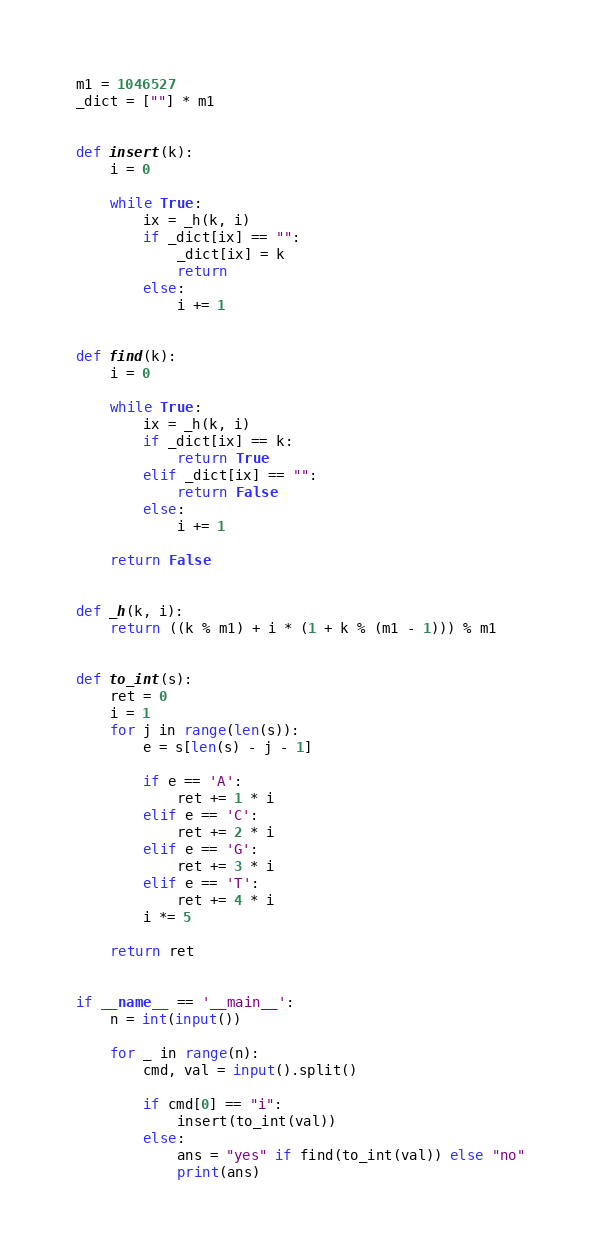Convert code to text. <code><loc_0><loc_0><loc_500><loc_500><_Python_>m1 = 1046527
_dict = [""] * m1


def insert(k):
    i = 0

    while True:
        ix = _h(k, i)
        if _dict[ix] == "":
            _dict[ix] = k
            return
        else:
            i += 1


def find(k):
    i = 0

    while True:
        ix = _h(k, i)
        if _dict[ix] == k:
            return True
        elif _dict[ix] == "":
            return False
        else:
            i += 1

    return False


def _h(k, i):
    return ((k % m1) + i * (1 + k % (m1 - 1))) % m1


def to_int(s):
    ret = 0
    i = 1
    for j in range(len(s)):
        e = s[len(s) - j - 1]

        if e == 'A':
            ret += 1 * i
        elif e == 'C':
            ret += 2 * i
        elif e == 'G':
            ret += 3 * i
        elif e == 'T':
            ret += 4 * i
        i *= 5

    return ret


if __name__ == '__main__':
    n = int(input())

    for _ in range(n):
        cmd, val = input().split()

        if cmd[0] == "i":
            insert(to_int(val))
        else:
            ans = "yes" if find(to_int(val)) else "no"
            print(ans)</code> 